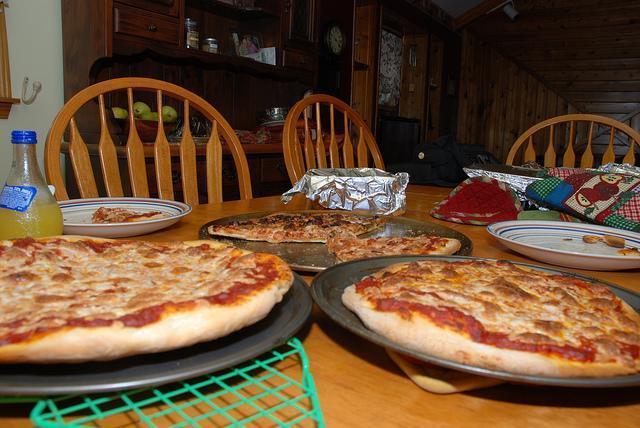How many pizza that has not been eaten?
Give a very brief answer. 2. How many bottles can you see?
Give a very brief answer. 1. How many chairs are there?
Give a very brief answer. 3. How many pizzas are there?
Give a very brief answer. 4. How many people are not on the bus?
Give a very brief answer. 0. 